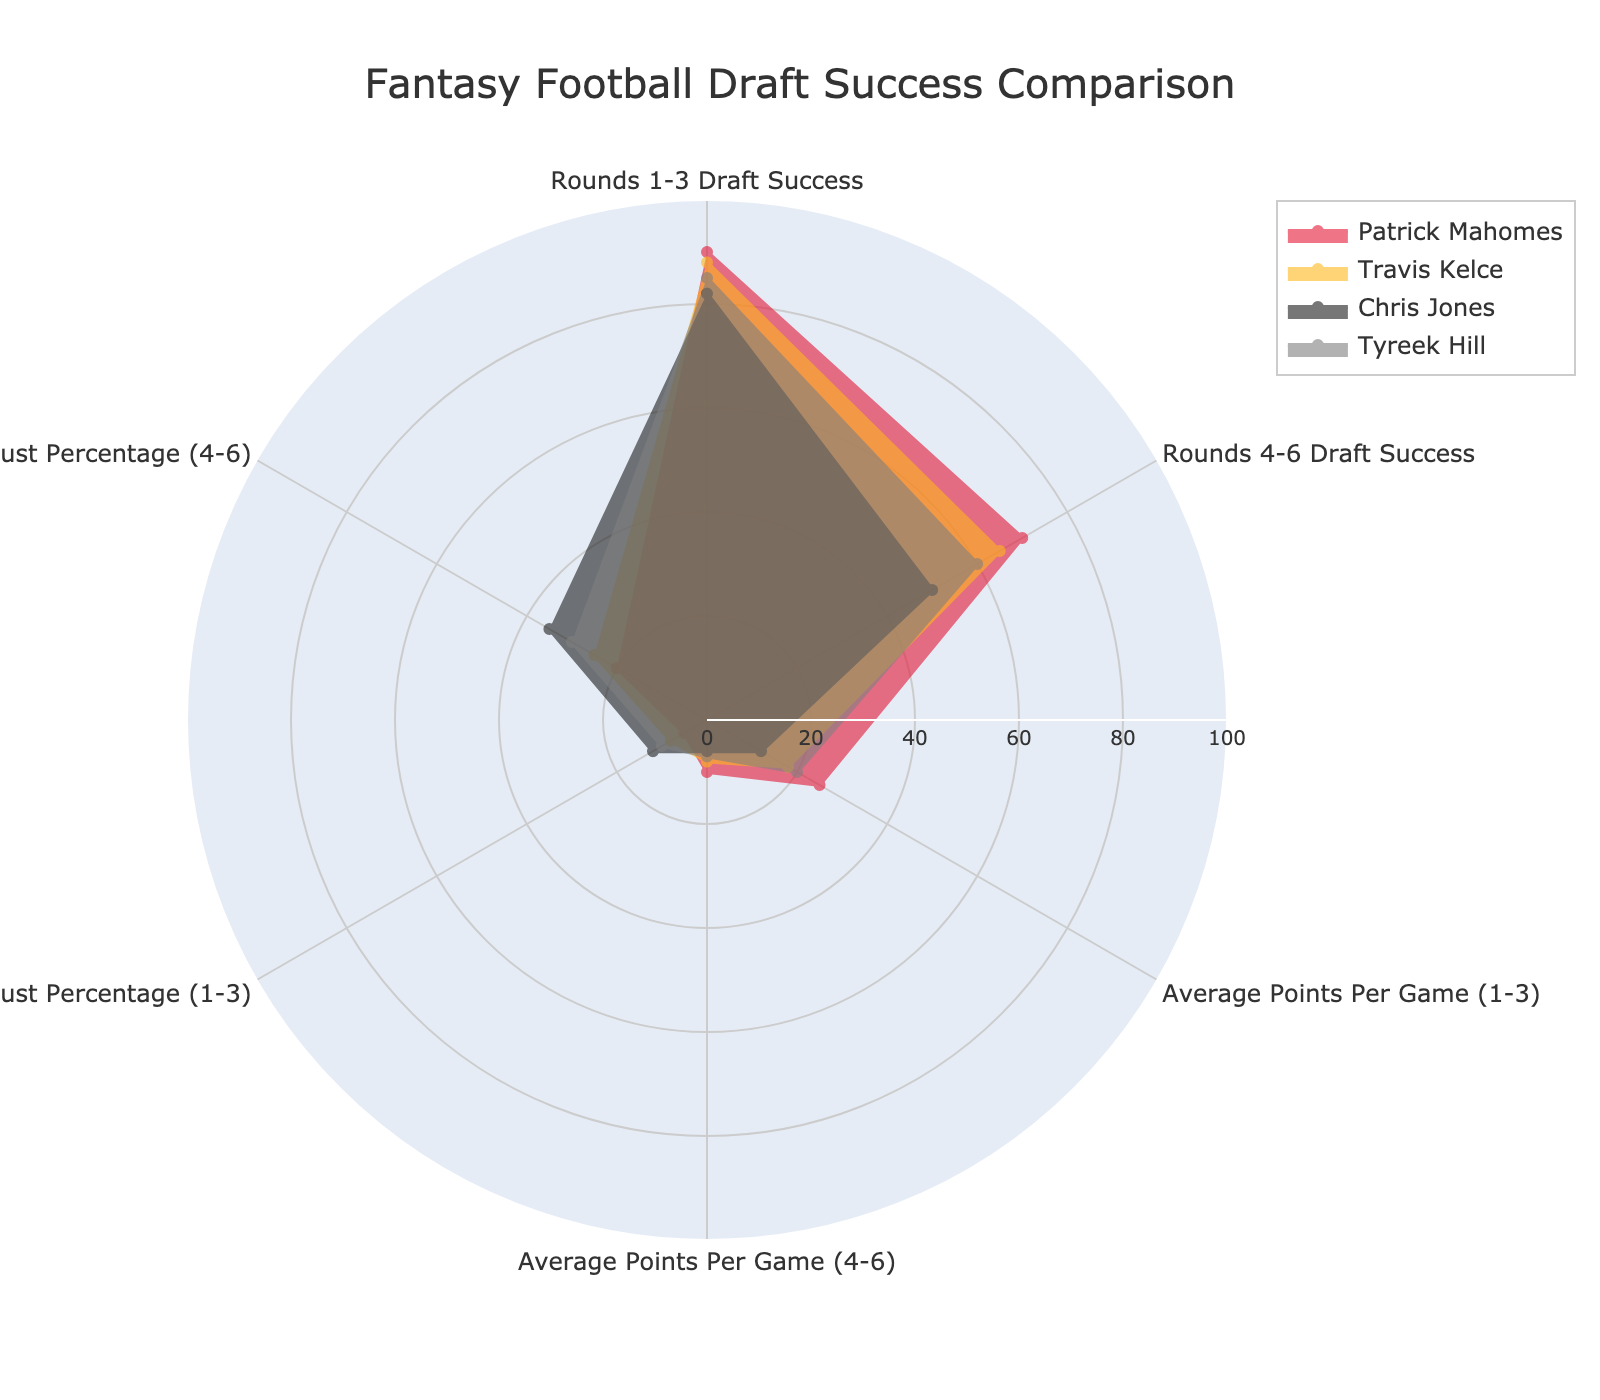What is the title of the radar chart? The title of the radar chart is visually centered at the top in larger text. This title helps identify the overall subject of the plot without needing to look at the data details.
Answer: Fantasy Football Draft Success Comparison Who has the highest "Rounds 1-3 Draft Success" score? By observing the "Rounds 1-3 Draft Success" data on the radar chart, we can identify the highest value, which is reflected by the longest point on the respective axis.
Answer: Patrick Mahomes What is the bust percentage for Chris Jones in Rounds 4-6? The radar chart shows the "Bust Percentage (4-6)" for each player. By locating Chris Jones's data point on that axis, we can observe the percentage directly.
Answer: 35 What is the difference between Travis Kelce's "Rounds 1-3 Draft Success" and his "Rounds 4-6 Draft Success"? To find this difference, subtract the "Rounds 4-6 Draft Success" score of Travis Kelce from his "Rounds 1-3 Draft Success" score by looking at the respective positions of both metrics on the radar plot.
Answer: 23 Who has the highest average points per game in Rounds 4-6? To identify which player performs best in terms of average points per game in Rounds 4-6, compare the respective data points on the "Average Points Per Game (4-6)" axis for all players.
Answer: Patrick Mahomes Who shows the lowest "Bust Percentage (1-3)" on the radar chart? Locate the "Bust Percentage (1-3)" axis on the chart and identify the player whose data point is the closest to the center, indicating the lowest percentage.
Answer: Patrick Mahomes What is the average "Rounds 4-6 Draft Success" score for all players? Calculate the average by summing the "Rounds 4-6 Draft Success" scores of all players and dividing by the number of players. (70 + 65 + 50 + 60) / 4 = 61.25
Answer: 61.25 Compare the "Average Points Per Game (1-3)" for Tyreek Hill and Travis Kelce. Who scores more? By examining the "Average Points Per Game (1-3)" axis for both Tyreek Hill and Travis Kelce, identify which value is larger.
Answer: Tyreek Hill Which player has the most significant difference between "Average Points Per Game (1-3)" and "Average Points Per Game (4-6)"? Calculate the difference for each player by subtracting "Average Points Per Game (4-6)" from "Average Points Per Game (1-3)" and compare the results. (Patrick Mahomes: 25-10=15, Travis Kelce: 18-8=10, Chris Jones: 12-6=6, Tyreek Hill: 20-7=13).
Answer: Patrick Mahomes 